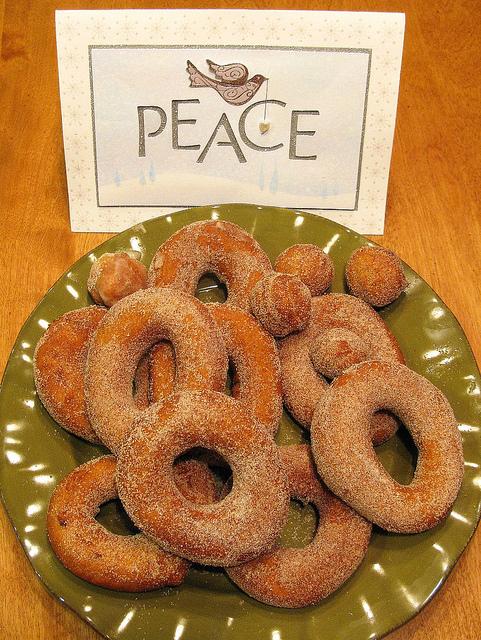Is this a typical thing left out for Santa?
Keep it brief. No. What are the white spots on the donuts?
Write a very short answer. Sugar. What does the card say?
Answer briefly. Peace. 